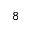Convert formula to latex. <formula><loc_0><loc_0><loc_500><loc_500>^ { 8 }</formula> 